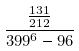Convert formula to latex. <formula><loc_0><loc_0><loc_500><loc_500>\frac { \frac { 1 3 1 } { 2 1 2 } } { 3 9 9 ^ { 6 } - 9 6 }</formula> 